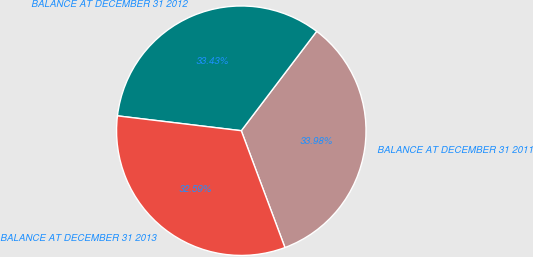Convert chart to OTSL. <chart><loc_0><loc_0><loc_500><loc_500><pie_chart><fcel>BALANCE AT DECEMBER 31 2011<fcel>BALANCE AT DECEMBER 31 2012<fcel>BALANCE AT DECEMBER 31 2013<nl><fcel>33.98%<fcel>33.43%<fcel>32.59%<nl></chart> 